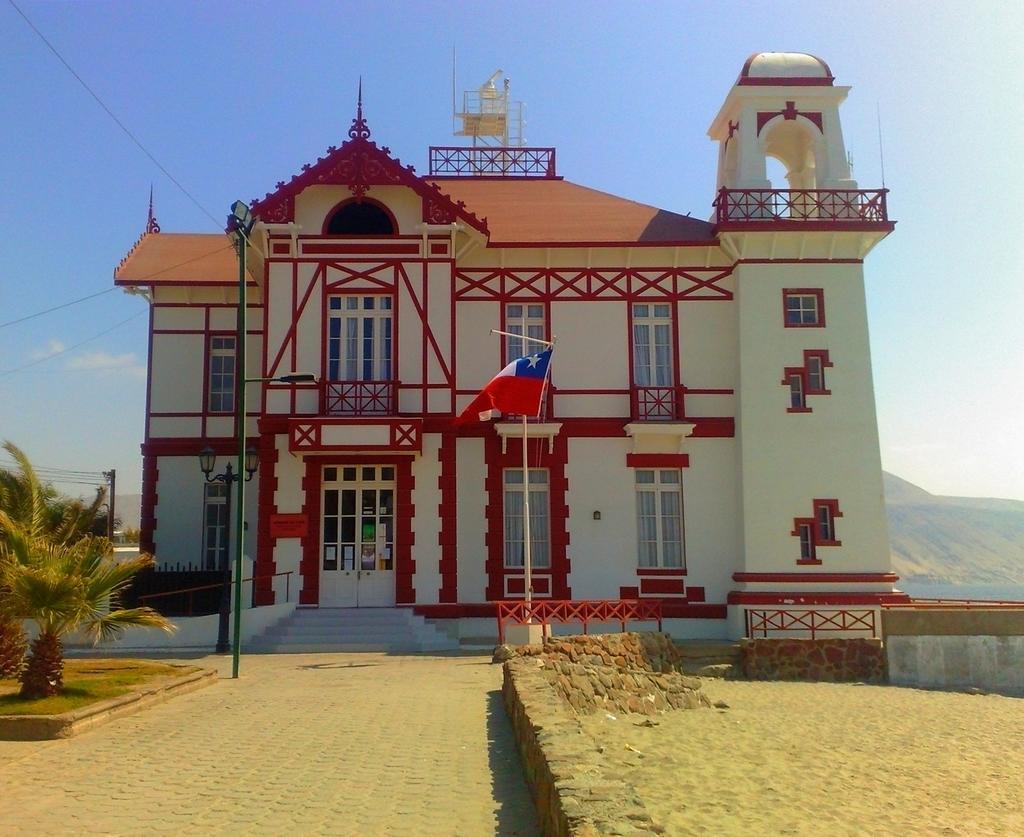Please provide a concise description of this image. In this image we can see a building. In the foreground we can see a pole with lights and wire. On the left side, we can see a plant. Behind the building we can see mountains. At the top we can see the sky. 